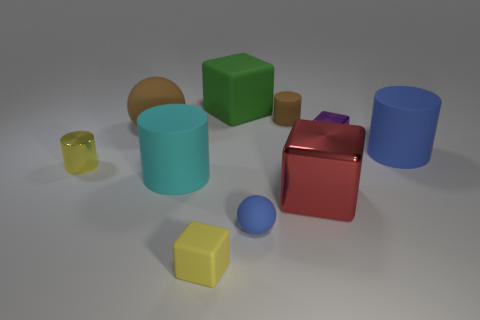Subtract all yellow blocks. Subtract all yellow cylinders. How many blocks are left? 3 Subtract all balls. How many objects are left? 8 Add 8 large green cylinders. How many large green cylinders exist? 8 Subtract 0 purple cylinders. How many objects are left? 10 Subtract all tiny purple shiny things. Subtract all tiny yellow rubber things. How many objects are left? 8 Add 5 cyan cylinders. How many cyan cylinders are left? 6 